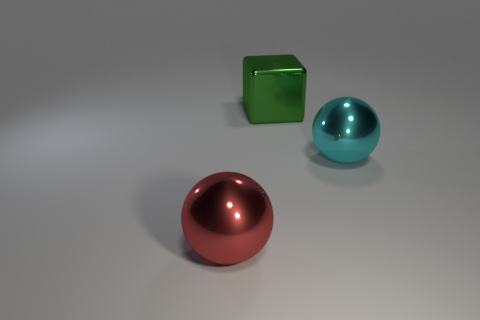Add 2 red balls. How many objects exist? 5 Subtract all balls. How many objects are left? 1 Add 3 big red balls. How many big red balls are left? 4 Add 1 big green shiny blocks. How many big green shiny blocks exist? 2 Subtract 0 green balls. How many objects are left? 3 Subtract all large yellow objects. Subtract all large red metal spheres. How many objects are left? 2 